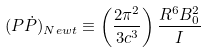<formula> <loc_0><loc_0><loc_500><loc_500>( P \dot { P } ) _ { N e w t } \equiv \left ( \frac { 2 \pi ^ { 2 } } { 3 c ^ { 3 } } \right ) \frac { R ^ { 6 } B ^ { 2 } _ { 0 } } { I } \</formula> 